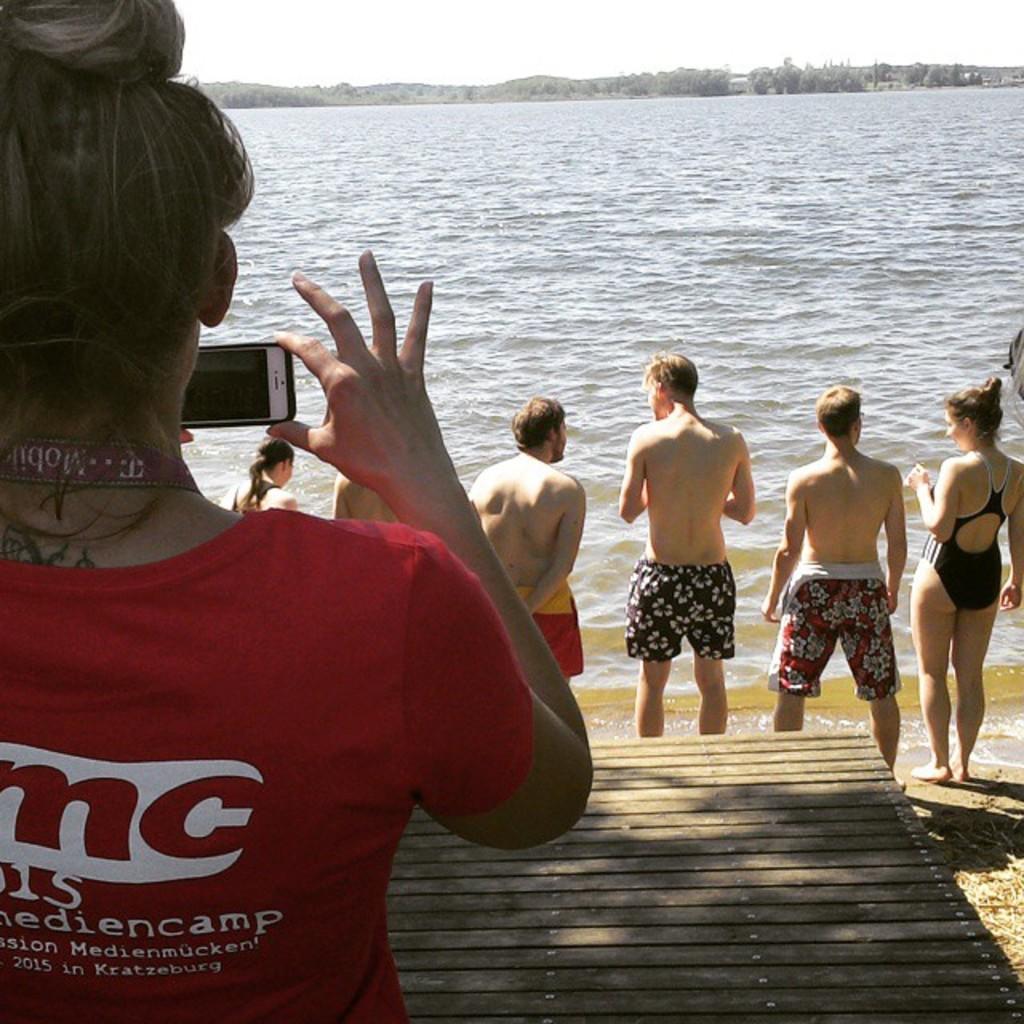Can you describe this image briefly? On the left side of the image we can see a woman holding a mobile phone. In the center of the image we can see group of persons standing at the water. In the background we can see water, trees and sky. 